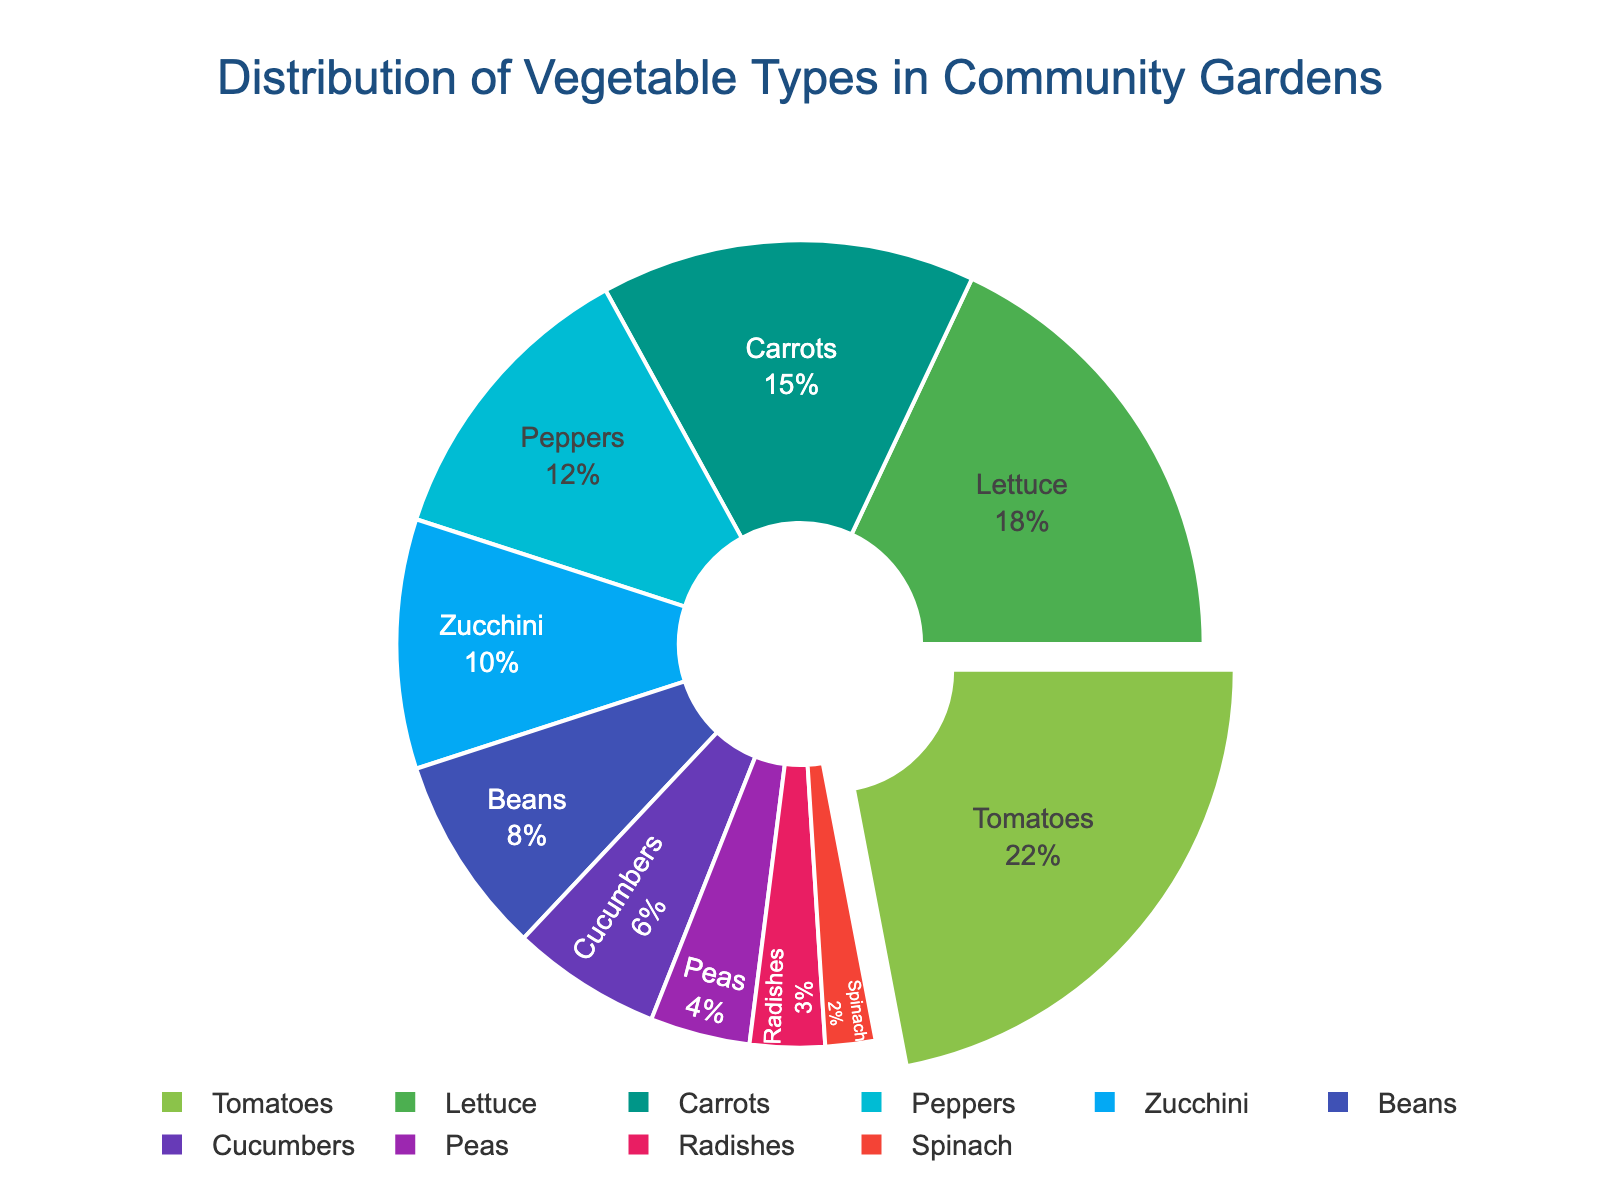What's the most common vegetable type grown in community gardens? The pie chart shows the proportions of different vegetable types grown in community gardens. The largest section of the pie chart represents tomatoes, with a percentage of 22%.
Answer: Tomatoes Which vegetable type has the smallest representation in the community gardens? By observing the pie chart's segments, we identify the smallest section. Spinach has the smallest slice, with a percentage of 2%.
Answer: Spinach What is the total percentage of tomatoes, lettuce, and carrots combined? To find the combined percentage, sum the individual percentages of tomatoes (22%), lettuce (18%), and carrots (15%). Thus, 22 + 18 + 15 = 55%.
Answer: 55% How many percentage points greater is the representation of peppers compared to cucumbers? The pie chart indicates peppers at 12% and cucumbers at 6%. The difference is calculated as 12 - 6 = 6 percentage points.
Answer: 6 Are tomatoes and beans together more than zucchini and peas combined? First, sum the percentages of tomatoes (22%) and beans (8%), which equals 30%. Then, sum zucchini (10%) and peas (4%), which equals 14%. Comparing the sums, 30% is greater than 14%.
Answer: Yes Which is more popular, lettuce or peppers? By examining the pie chart, lettuce has a larger slice at 18% compared to peppers at 12%. Therefore, lettuce is more popular.
Answer: Lettuce What color represents carrots in the pie chart? The colors in the pie chart proceed in a sequence matching the listed vegetables. Carrots are third in the list, so the corresponding segment is the third color in the sequence. The third color is a blueish-green.
Answer: Blueish-green Combining zucchini, beans, and peas, do they make up at least 20% of the vegetable types? Sum the percentages: zucchini (10%), beans (8%), and peas (4%). The total is 10 + 8 + 4 = 22%, which is indeed at least 20%.
Answer: Yes Is the proportion of zucchini more than twice the proportion of spinach? Zucchini represents 10% and spinach 2%. To see if zucchini is more than twice that of spinach, double spinach's percentage (2 * 2 = 4%). Since 10% is more than 4%, yes, it is more than twice.
Answer: Yes 